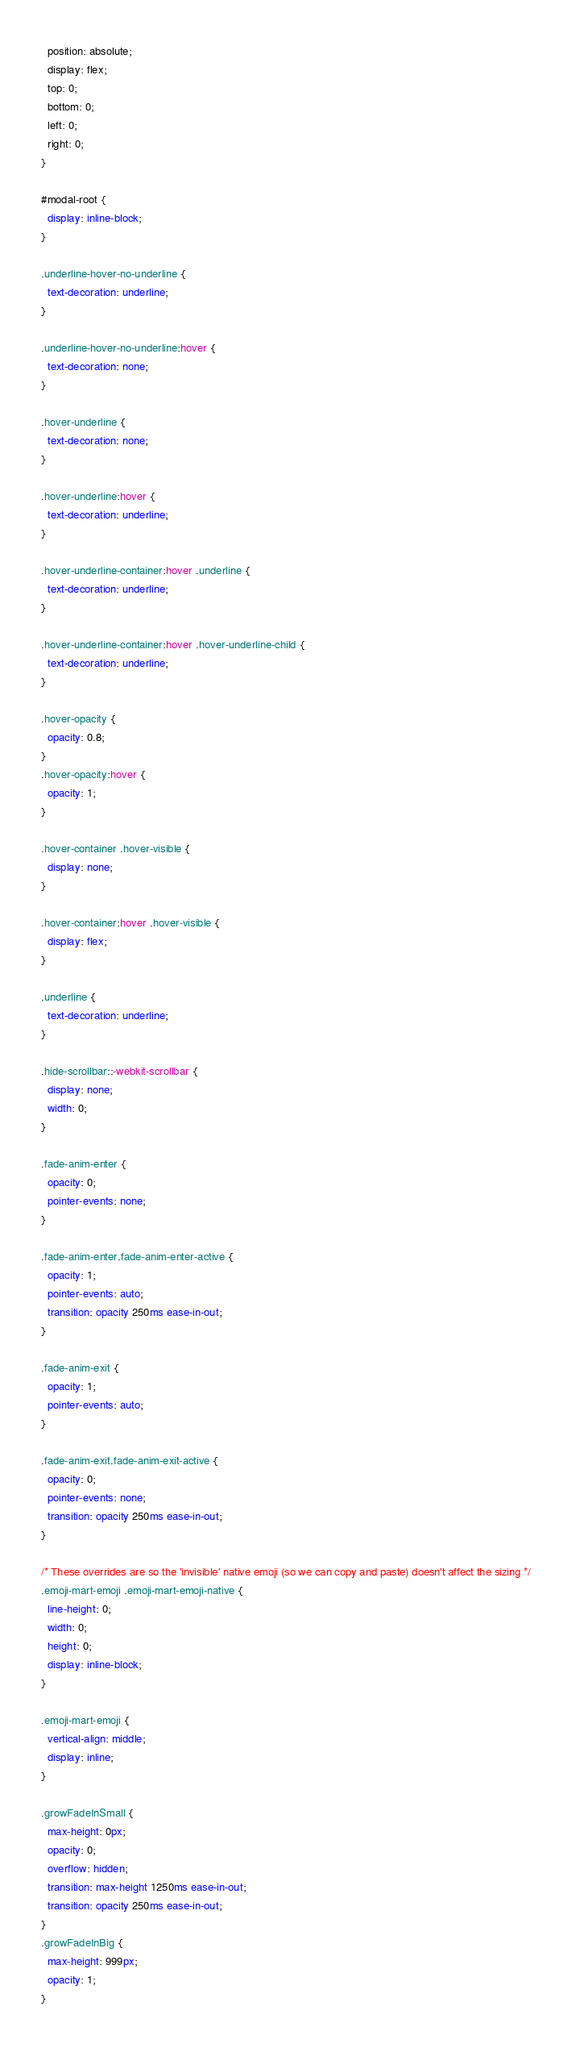Convert code to text. <code><loc_0><loc_0><loc_500><loc_500><_CSS_>  position: absolute;
  display: flex;
  top: 0;
  bottom: 0;
  left: 0;
  right: 0;
}

#modal-root {
  display: inline-block;
}

.underline-hover-no-underline {
  text-decoration: underline;
}

.underline-hover-no-underline:hover {
  text-decoration: none;
}

.hover-underline {
  text-decoration: none;
}

.hover-underline:hover {
  text-decoration: underline;
}

.hover-underline-container:hover .underline {
  text-decoration: underline;
}

.hover-underline-container:hover .hover-underline-child {
  text-decoration: underline;
}

.hover-opacity {
  opacity: 0.8;
}
.hover-opacity:hover {
  opacity: 1;
}

.hover-container .hover-visible {
  display: none;
}

.hover-container:hover .hover-visible {
  display: flex;
}

.underline {
  text-decoration: underline;
}

.hide-scrollbar::-webkit-scrollbar {
  display: none;
  width: 0;
}

.fade-anim-enter {
  opacity: 0;
  pointer-events: none;
}

.fade-anim-enter.fade-anim-enter-active {
  opacity: 1;
  pointer-events: auto;
  transition: opacity 250ms ease-in-out;
}

.fade-anim-exit {
  opacity: 1;
  pointer-events: auto;
}

.fade-anim-exit.fade-anim-exit-active {
  opacity: 0;
  pointer-events: none;
  transition: opacity 250ms ease-in-out;
}

/* These overrides are so the 'invisible' native emoji (so we can copy and paste) doesn't affect the sizing */
.emoji-mart-emoji .emoji-mart-emoji-native {
  line-height: 0;
  width: 0;
  height: 0;
  display: inline-block;
}

.emoji-mart-emoji {
  vertical-align: middle;
  display: inline;
}

.growFadeInSmall {
  max-height: 0px;
  opacity: 0;
  overflow: hidden;
  transition: max-height 1250ms ease-in-out;
  transition: opacity 250ms ease-in-out;
}
.growFadeInBig {
  max-height: 999px;
  opacity: 1;
}
</code> 